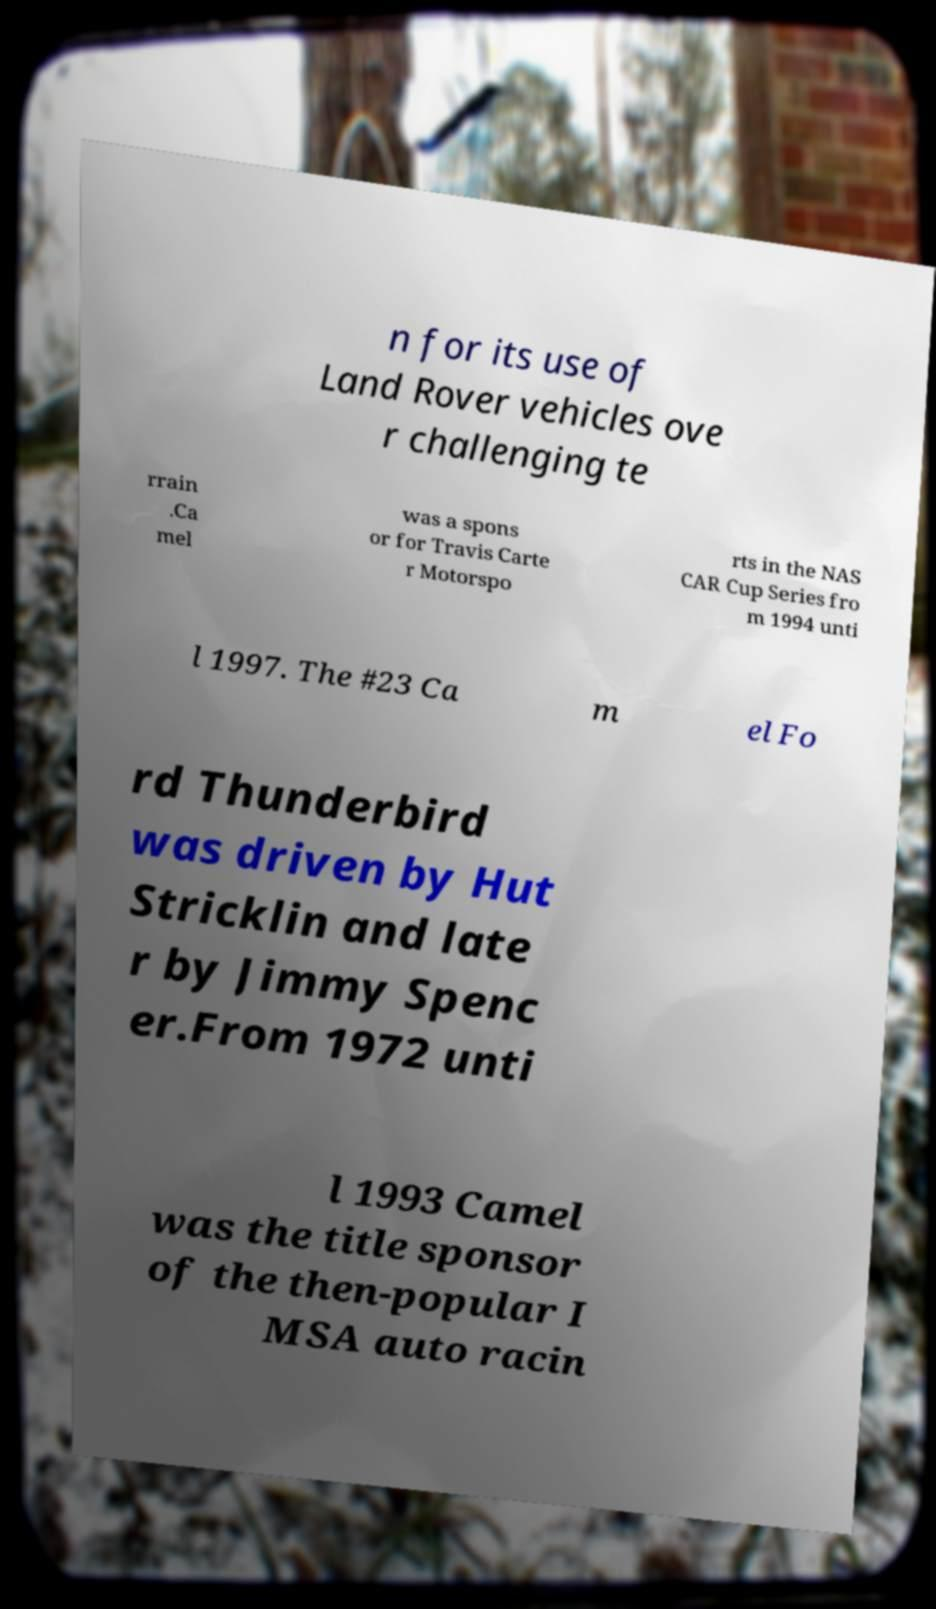Please identify and transcribe the text found in this image. n for its use of Land Rover vehicles ove r challenging te rrain .Ca mel was a spons or for Travis Carte r Motorspo rts in the NAS CAR Cup Series fro m 1994 unti l 1997. The #23 Ca m el Fo rd Thunderbird was driven by Hut Stricklin and late r by Jimmy Spenc er.From 1972 unti l 1993 Camel was the title sponsor of the then-popular I MSA auto racin 